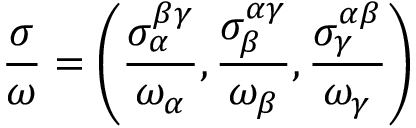Convert formula to latex. <formula><loc_0><loc_0><loc_500><loc_500>\frac { \sigma } { \omega } = \left ( \frac { \sigma _ { \alpha } ^ { \beta \gamma } } { \omega _ { \alpha } } , \frac { \sigma _ { \beta } ^ { \alpha \gamma } } { \omega _ { \beta } } , \frac { \sigma _ { \gamma } ^ { \alpha \beta } } { \omega _ { \gamma } } \right )</formula> 